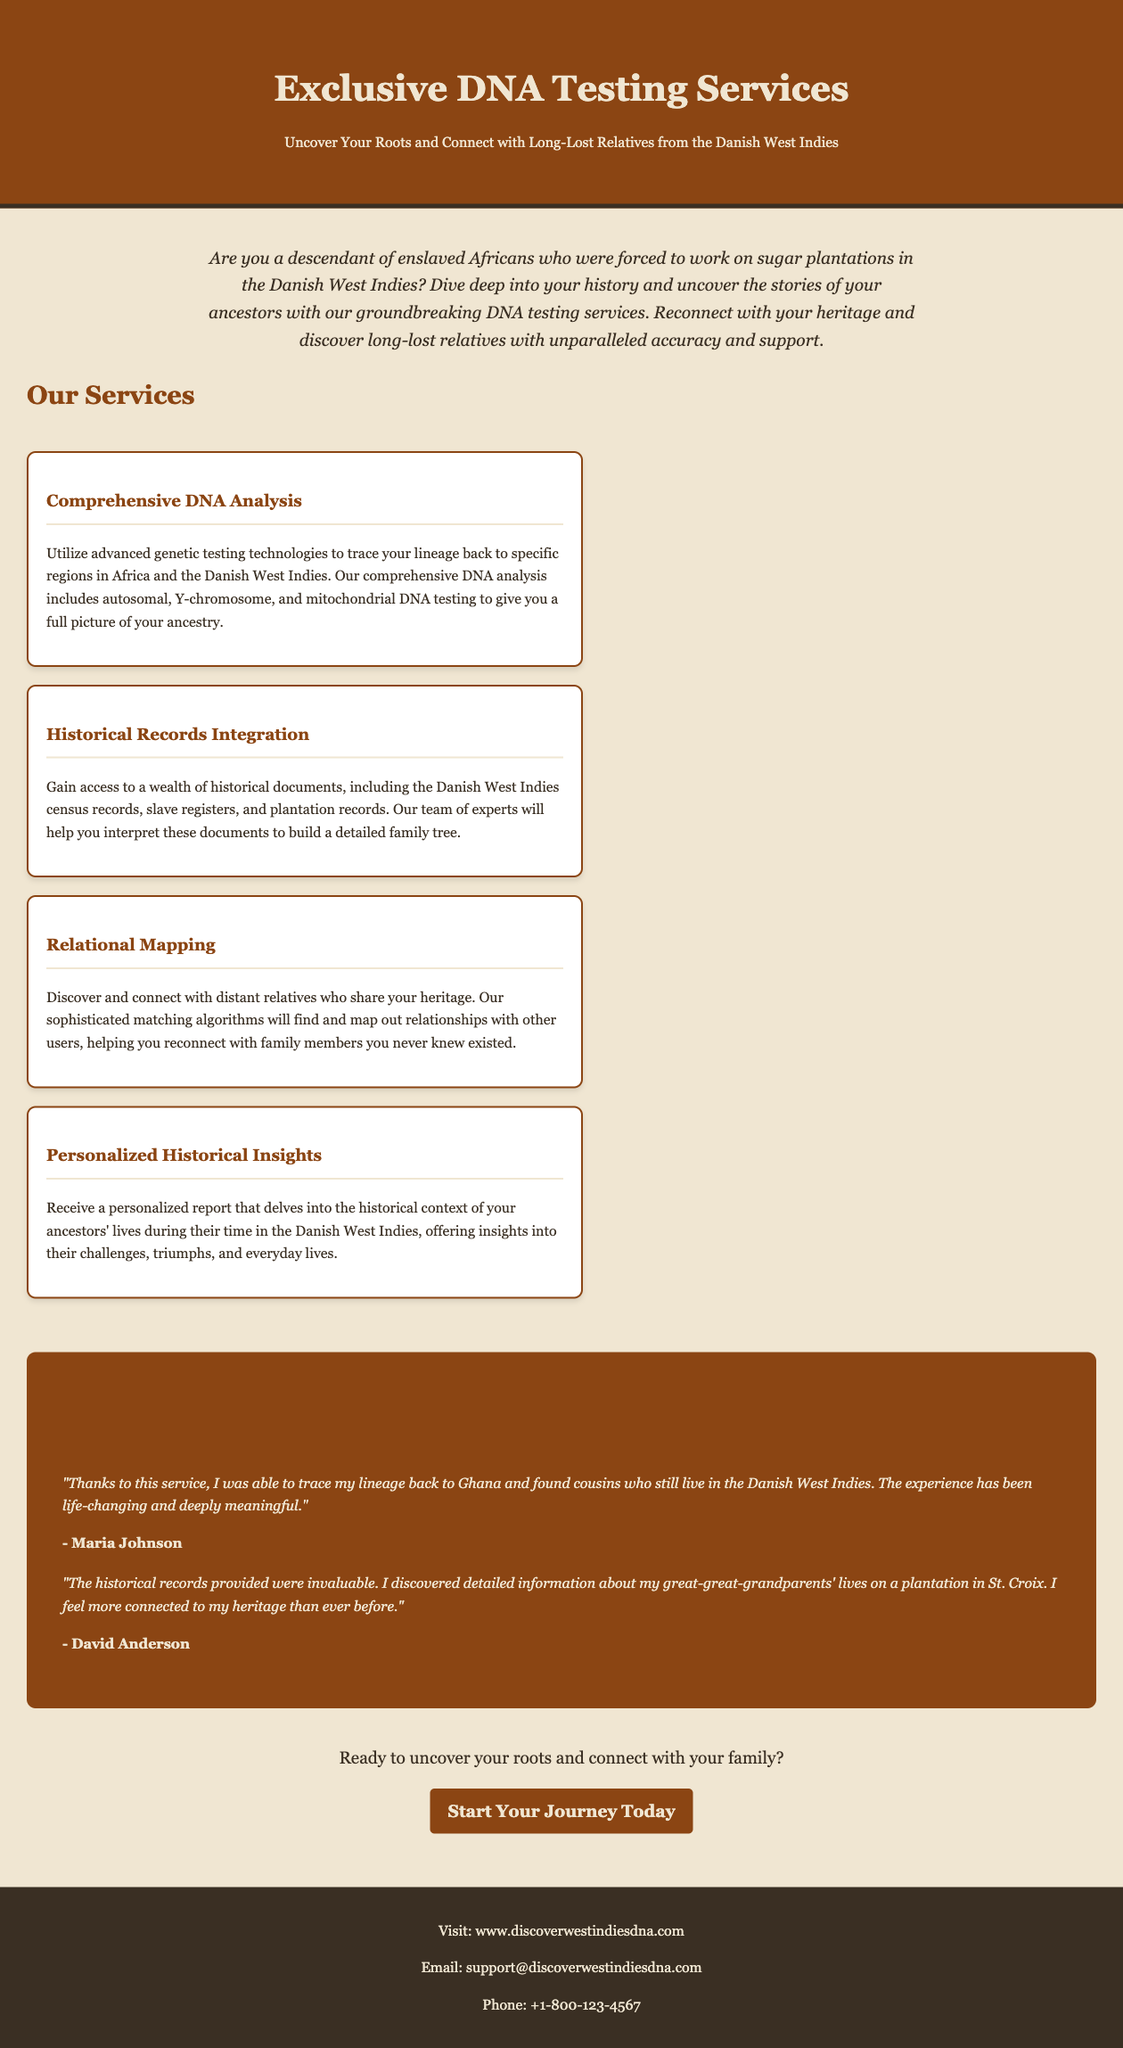What is the focus of the DNA testing services? The focus of the DNA testing services is to help uncover roots and connect with long-lost relatives from the Danish West Indies.
Answer: uncover roots and connect with long-lost relatives What type of DNA tests are mentioned? The document mentions autosomal, Y-chromosome, and mitochondrial DNA testing as part of the comprehensive DNA analysis.
Answer: autosomal, Y-chromosome, mitochondrial What is the contact email for the service? The email provided in the footer for contact is support@discoverwestindiesdna.com.
Answer: support@discoverwestindiesdna.com How many testimonials are shared in the document? The document contains two customer testimonials highlighting their experiences with the service.
Answer: two What is the title of the first service listed? The first service listed in the document is "Comprehensive DNA Analysis."
Answer: Comprehensive DNA Analysis What does the service offer in terms of historical records? The service offers access to historical documents including census records, slave registers, and plantation records.
Answer: census records, slave registers, plantation records How does the service aim to help customers connect with relatives? The service uses sophisticated matching algorithms to find and map out relationships with other users.
Answer: sophisticated matching algorithms Who is quoted in the first testimonial? The name mentioned in the first testimonial is Maria Johnson, who shares her positive experience with tracing her lineage.
Answer: Maria Johnson 